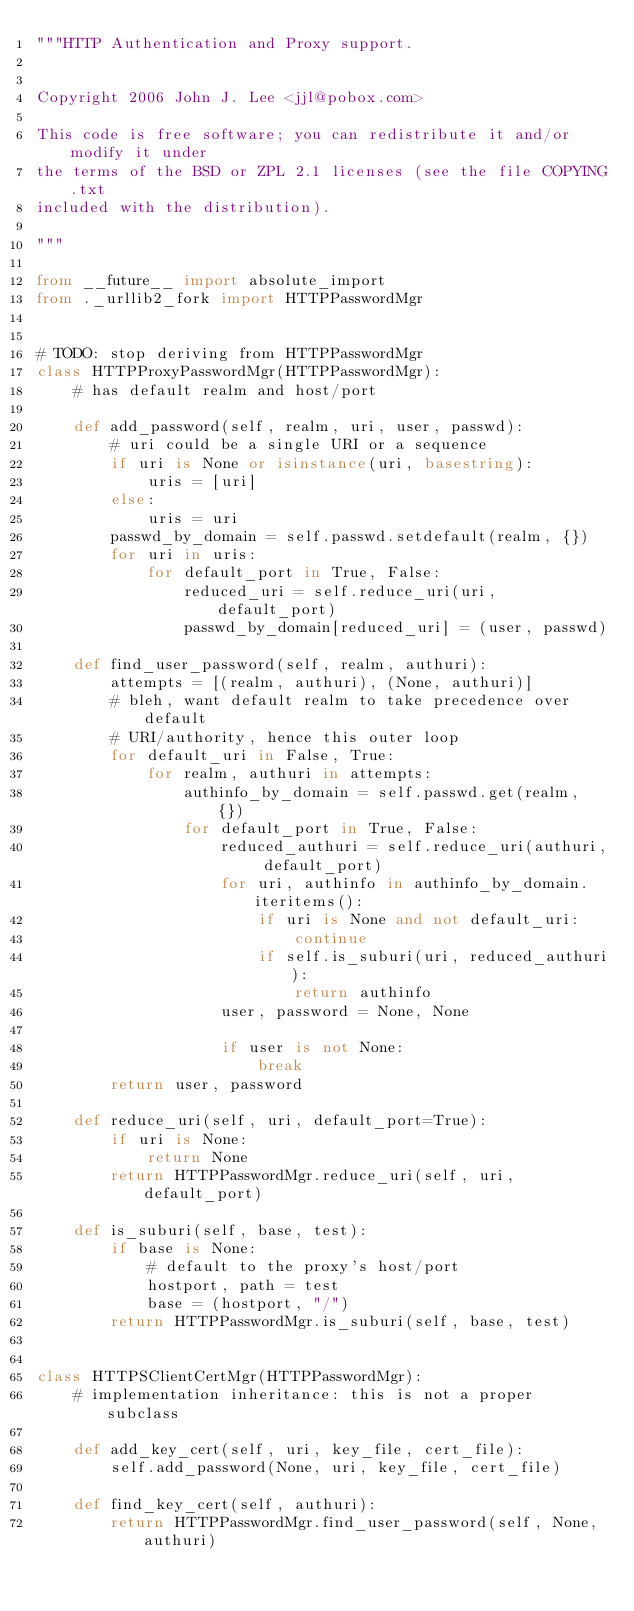<code> <loc_0><loc_0><loc_500><loc_500><_Python_>"""HTTP Authentication and Proxy support.


Copyright 2006 John J. Lee <jjl@pobox.com>

This code is free software; you can redistribute it and/or modify it under
the terms of the BSD or ZPL 2.1 licenses (see the file COPYING.txt
included with the distribution).

"""

from __future__ import absolute_import
from ._urllib2_fork import HTTPPasswordMgr


# TODO: stop deriving from HTTPPasswordMgr
class HTTPProxyPasswordMgr(HTTPPasswordMgr):
    # has default realm and host/port

    def add_password(self, realm, uri, user, passwd):
        # uri could be a single URI or a sequence
        if uri is None or isinstance(uri, basestring):
            uris = [uri]
        else:
            uris = uri
        passwd_by_domain = self.passwd.setdefault(realm, {})
        for uri in uris:
            for default_port in True, False:
                reduced_uri = self.reduce_uri(uri, default_port)
                passwd_by_domain[reduced_uri] = (user, passwd)

    def find_user_password(self, realm, authuri):
        attempts = [(realm, authuri), (None, authuri)]
        # bleh, want default realm to take precedence over default
        # URI/authority, hence this outer loop
        for default_uri in False, True:
            for realm, authuri in attempts:
                authinfo_by_domain = self.passwd.get(realm, {})
                for default_port in True, False:
                    reduced_authuri = self.reduce_uri(authuri, default_port)
                    for uri, authinfo in authinfo_by_domain.iteritems():
                        if uri is None and not default_uri:
                            continue
                        if self.is_suburi(uri, reduced_authuri):
                            return authinfo
                    user, password = None, None

                    if user is not None:
                        break
        return user, password

    def reduce_uri(self, uri, default_port=True):
        if uri is None:
            return None
        return HTTPPasswordMgr.reduce_uri(self, uri, default_port)

    def is_suburi(self, base, test):
        if base is None:
            # default to the proxy's host/port
            hostport, path = test
            base = (hostport, "/")
        return HTTPPasswordMgr.is_suburi(self, base, test)


class HTTPSClientCertMgr(HTTPPasswordMgr):
    # implementation inheritance: this is not a proper subclass

    def add_key_cert(self, uri, key_file, cert_file):
        self.add_password(None, uri, key_file, cert_file)

    def find_key_cert(self, authuri):
        return HTTPPasswordMgr.find_user_password(self, None, authuri)
</code> 